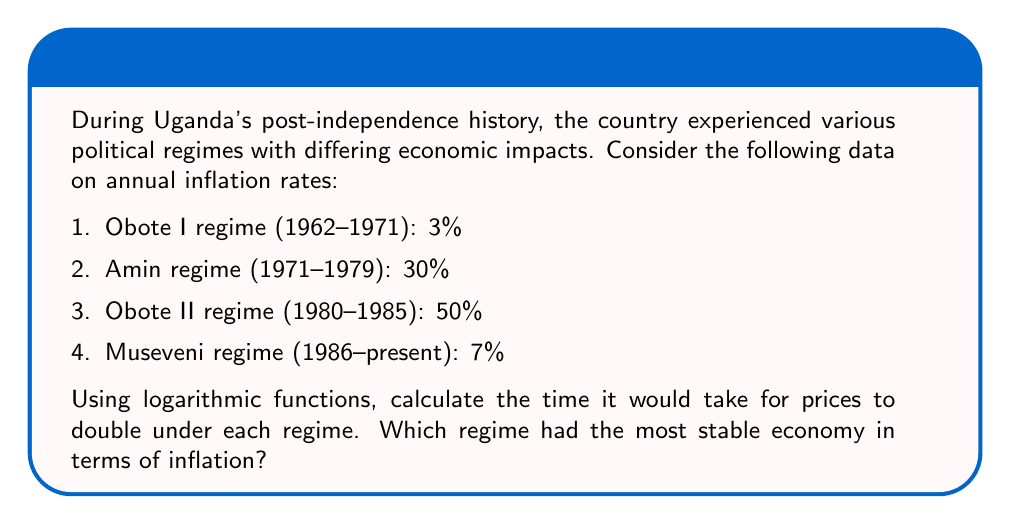Provide a solution to this math problem. To solve this problem, we'll use the compound interest formula and logarithms. The formula for the time it takes for a value to double with continuous compound interest is:

$$ T = \frac{\ln(2)}{r} $$

Where $T$ is the time to double, and $r$ is the annual inflation rate expressed as a decimal.

Let's calculate for each regime:

1. Obote I regime (1962-1971):
   $r = 0.03$
   $$ T = \frac{\ln(2)}{0.03} \approx 23.10 \text{ years} $$

2. Amin regime (1971-1979):
   $r = 0.30$
   $$ T = \frac{\ln(2)}{0.30} \approx 2.31 \text{ years} $$

3. Obote II regime (1980-1985):
   $r = 0.50$
   $$ T = \frac{\ln(2)}{0.50} \approx 1.39 \text{ years} $$

4. Museveni regime (1986-present):
   $r = 0.07$
   $$ T = \frac{\ln(2)}{0.07} \approx 9.90 \text{ years} $$

The regime with the longest doubling time has the most stable economy in terms of inflation, as prices increase more slowly. In this case, the Obote I regime had the longest doubling time of approximately 23.10 years, indicating the most stable economy with respect to inflation.
Answer: The Obote I regime (1962-1971) had the most stable economy in terms of inflation, with prices taking approximately 23.10 years to double. 